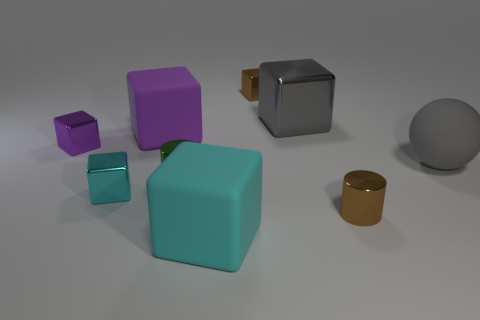How many cyan cubes must be subtracted to get 1 cyan cubes? 1 Subtract all brown blocks. How many blocks are left? 5 Subtract all large purple matte blocks. How many blocks are left? 5 Subtract all brown cubes. Subtract all gray cylinders. How many cubes are left? 5 Add 1 small blue shiny cylinders. How many objects exist? 10 Subtract all blocks. How many objects are left? 3 Add 9 green metal cylinders. How many green metal cylinders exist? 10 Subtract 0 red cylinders. How many objects are left? 9 Subtract all big gray things. Subtract all large metallic objects. How many objects are left? 6 Add 9 balls. How many balls are left? 10 